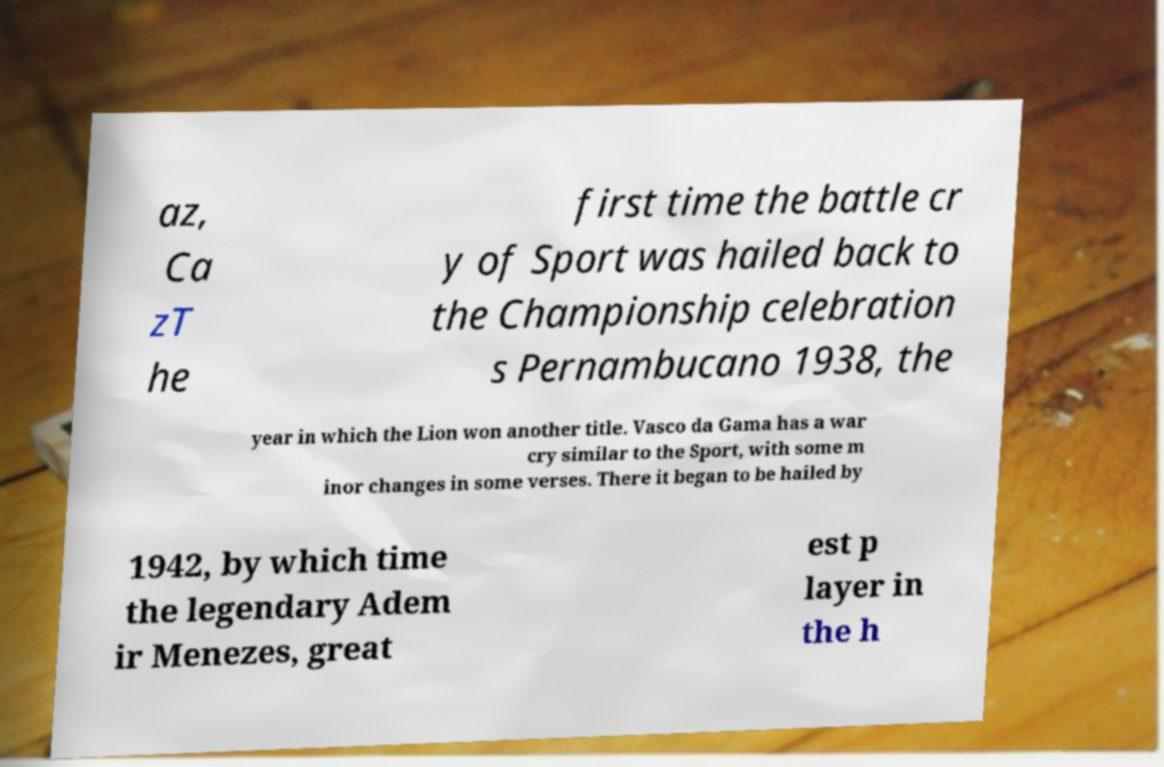Could you assist in decoding the text presented in this image and type it out clearly? az, Ca zT he first time the battle cr y of Sport was hailed back to the Championship celebration s Pernambucano 1938, the year in which the Lion won another title. Vasco da Gama has a war cry similar to the Sport, with some m inor changes in some verses. There it began to be hailed by 1942, by which time the legendary Adem ir Menezes, great est p layer in the h 